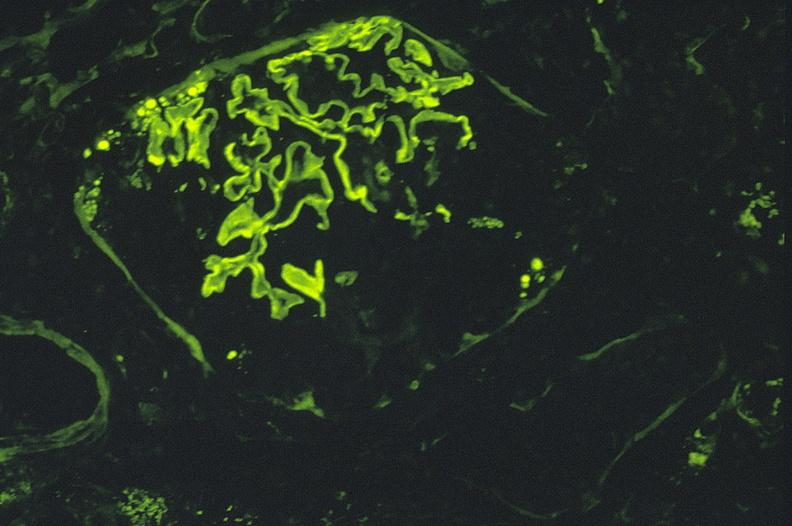s cut edge of mesentery present?
Answer the question using a single word or phrase. No 